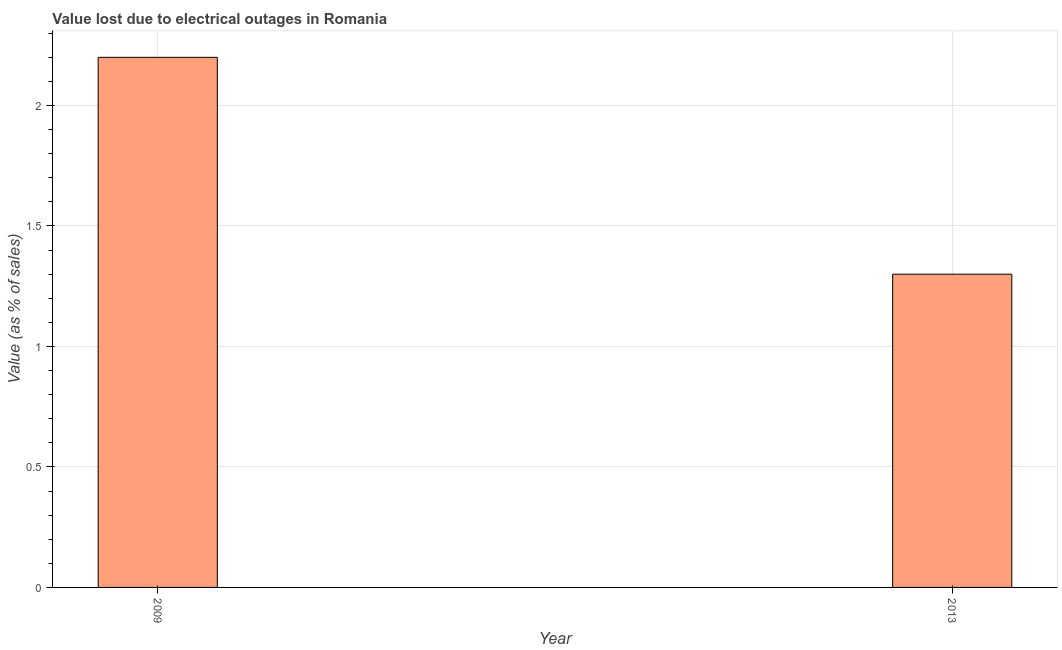Does the graph contain any zero values?
Your response must be concise. No. What is the title of the graph?
Ensure brevity in your answer.  Value lost due to electrical outages in Romania. What is the label or title of the Y-axis?
Offer a very short reply. Value (as % of sales). What is the value lost due to electrical outages in 2013?
Offer a terse response. 1.3. Across all years, what is the minimum value lost due to electrical outages?
Your answer should be very brief. 1.3. What is the difference between the value lost due to electrical outages in 2009 and 2013?
Keep it short and to the point. 0.9. What is the average value lost due to electrical outages per year?
Your answer should be compact. 1.75. What is the median value lost due to electrical outages?
Give a very brief answer. 1.75. Do a majority of the years between 2009 and 2013 (inclusive) have value lost due to electrical outages greater than 0.1 %?
Provide a short and direct response. Yes. What is the ratio of the value lost due to electrical outages in 2009 to that in 2013?
Keep it short and to the point. 1.69. In how many years, is the value lost due to electrical outages greater than the average value lost due to electrical outages taken over all years?
Provide a succinct answer. 1. What is the difference between two consecutive major ticks on the Y-axis?
Offer a terse response. 0.5. Are the values on the major ticks of Y-axis written in scientific E-notation?
Offer a very short reply. No. What is the Value (as % of sales) in 2009?
Give a very brief answer. 2.2. What is the difference between the Value (as % of sales) in 2009 and 2013?
Your response must be concise. 0.9. What is the ratio of the Value (as % of sales) in 2009 to that in 2013?
Provide a succinct answer. 1.69. 